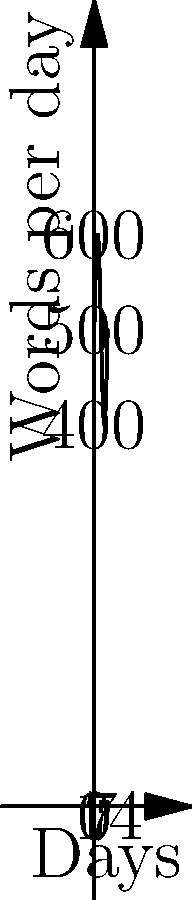The graph represents the number of words an author writes per day over a two-week period. The function modeling this data is given by $f(x) = 500 + 100\sin(\frac{\pi x}{7})$, where $x$ is the number of days. Calculate the total number of words written over the 14-day period. To find the total number of words written, we need to calculate the area under the curve over the 14-day period. This can be done using a definite integral.

1) The integral we need to evaluate is:
   $$\int_0^{14} (500 + 100\sin(\frac{\pi x}{7})) dx$$

2) Let's break this into two parts:
   $$\int_0^{14} 500 dx + \int_0^{14} 100\sin(\frac{\pi x}{7}) dx$$

3) For the first part:
   $$\int_0^{14} 500 dx = 500x \big|_0^{14} = 500(14) - 500(0) = 7000$$

4) For the second part, we use the substitution $u = \frac{\pi x}{7}$:
   $$\int_0^{14} 100\sin(\frac{\pi x}{7}) dx = \frac{700}{\pi} \int_0^{2\pi} \sin(u) du$$

5) We know that $\int \sin(u) du = -\cos(u) + C$, so:
   $$\frac{700}{\pi} [-\cos(u)]_0^{2\pi} = \frac{700}{\pi} [-\cos(2\pi) + \cos(0)] = 0$$

6) Adding the results from steps 3 and 5:
   Total words = 7000 + 0 = 7000
Answer: 7000 words 